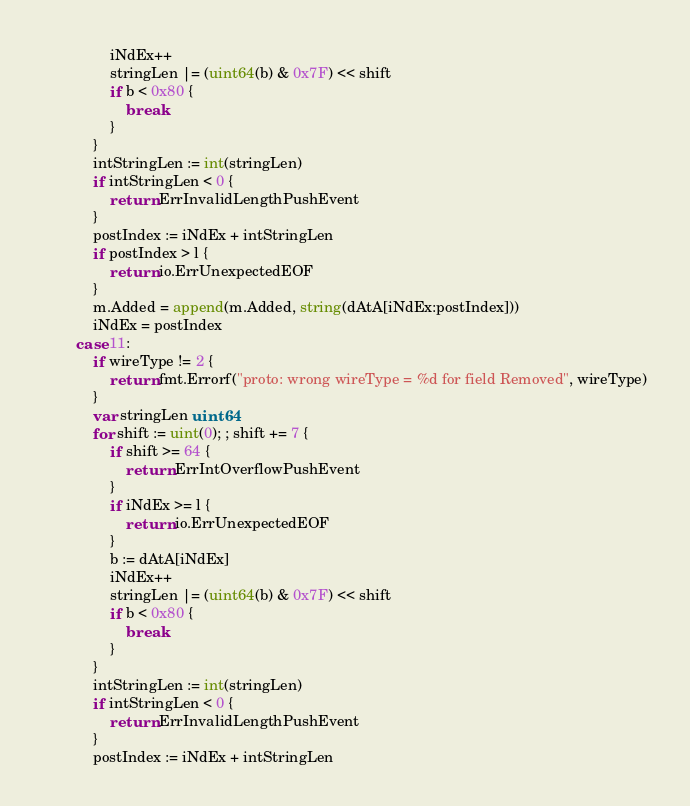<code> <loc_0><loc_0><loc_500><loc_500><_Go_>				iNdEx++
				stringLen |= (uint64(b) & 0x7F) << shift
				if b < 0x80 {
					break
				}
			}
			intStringLen := int(stringLen)
			if intStringLen < 0 {
				return ErrInvalidLengthPushEvent
			}
			postIndex := iNdEx + intStringLen
			if postIndex > l {
				return io.ErrUnexpectedEOF
			}
			m.Added = append(m.Added, string(dAtA[iNdEx:postIndex]))
			iNdEx = postIndex
		case 11:
			if wireType != 2 {
				return fmt.Errorf("proto: wrong wireType = %d for field Removed", wireType)
			}
			var stringLen uint64
			for shift := uint(0); ; shift += 7 {
				if shift >= 64 {
					return ErrIntOverflowPushEvent
				}
				if iNdEx >= l {
					return io.ErrUnexpectedEOF
				}
				b := dAtA[iNdEx]
				iNdEx++
				stringLen |= (uint64(b) & 0x7F) << shift
				if b < 0x80 {
					break
				}
			}
			intStringLen := int(stringLen)
			if intStringLen < 0 {
				return ErrInvalidLengthPushEvent
			}
			postIndex := iNdEx + intStringLen</code> 